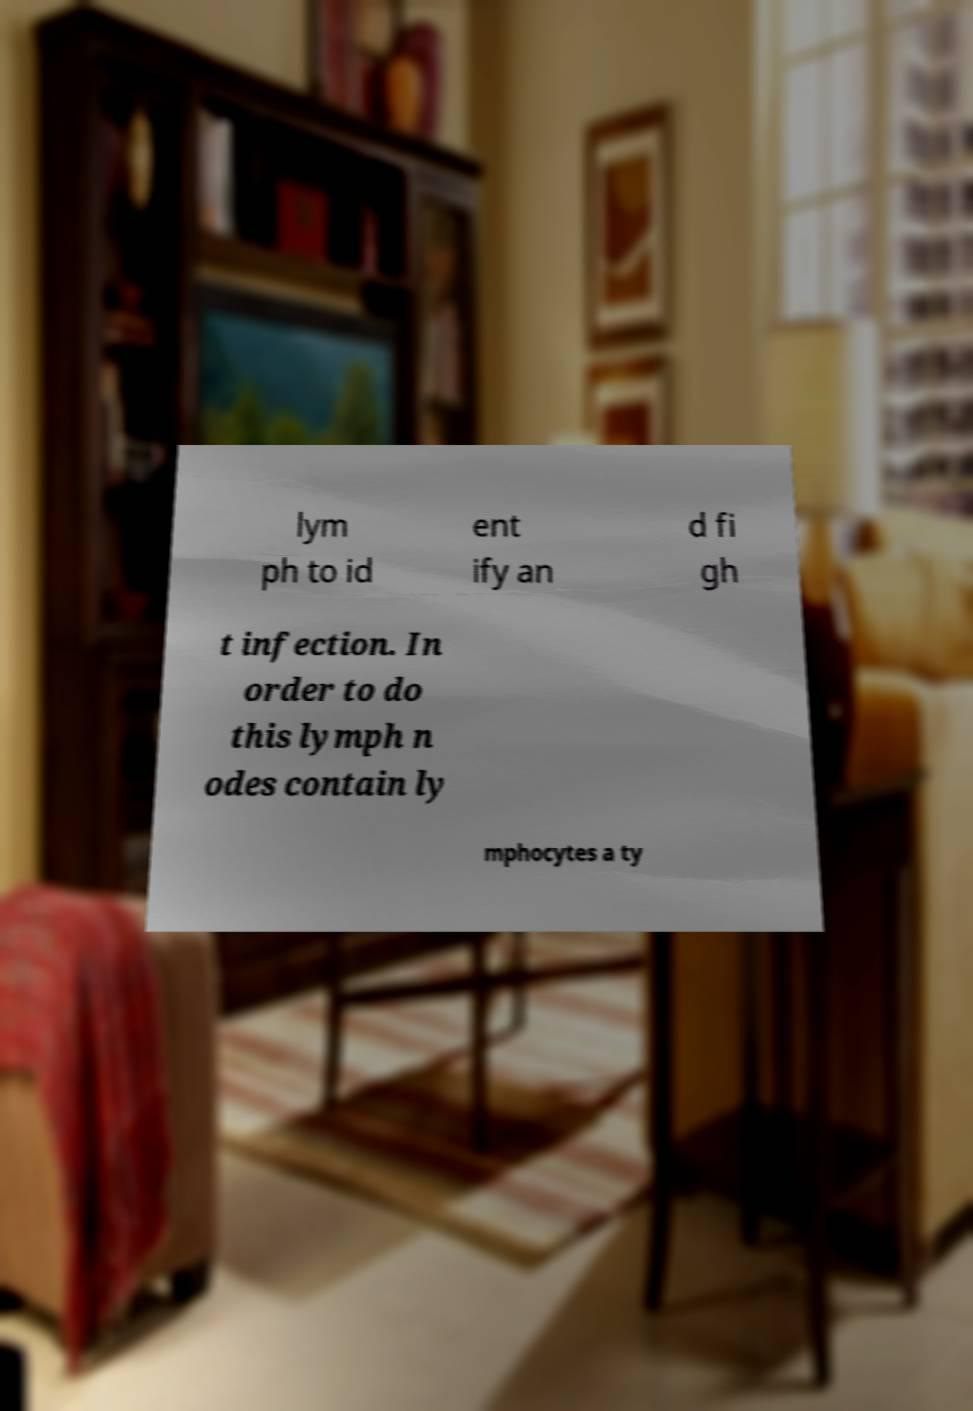Could you assist in decoding the text presented in this image and type it out clearly? lym ph to id ent ify an d fi gh t infection. In order to do this lymph n odes contain ly mphocytes a ty 